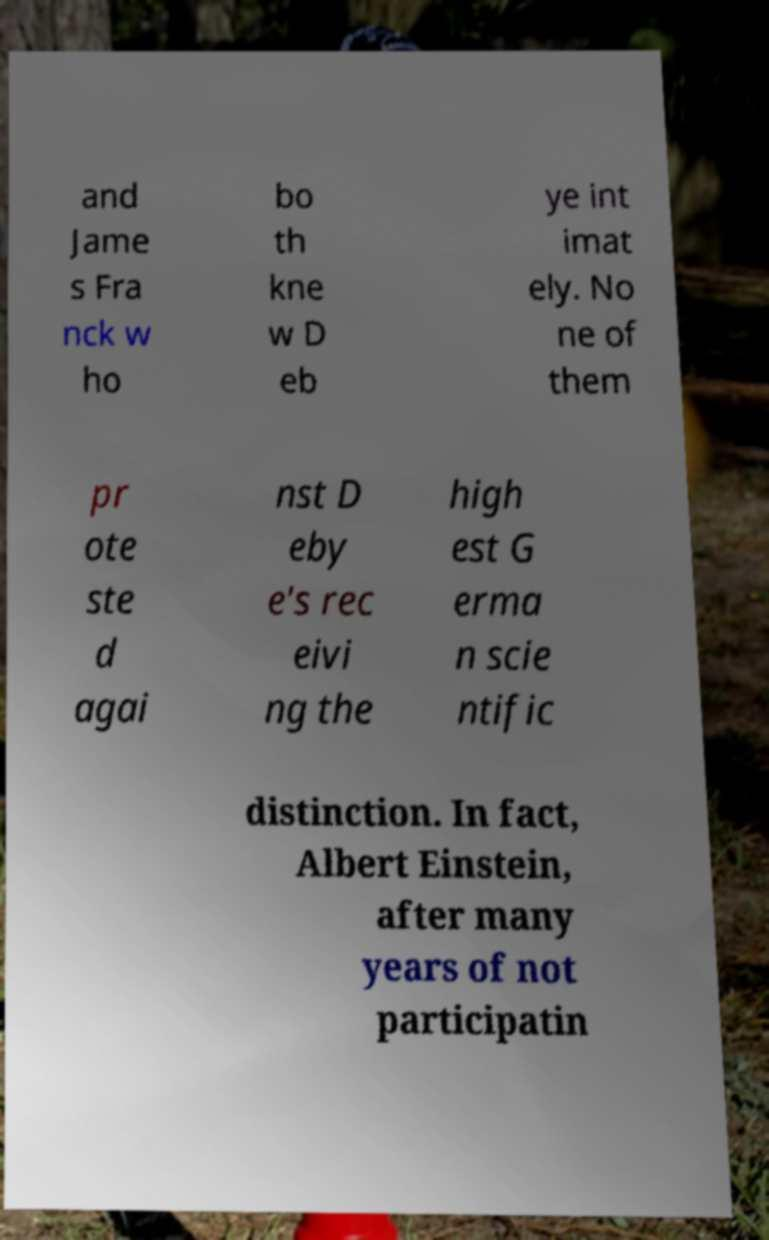Please identify and transcribe the text found in this image. and Jame s Fra nck w ho bo th kne w D eb ye int imat ely. No ne of them pr ote ste d agai nst D eby e's rec eivi ng the high est G erma n scie ntific distinction. In fact, Albert Einstein, after many years of not participatin 